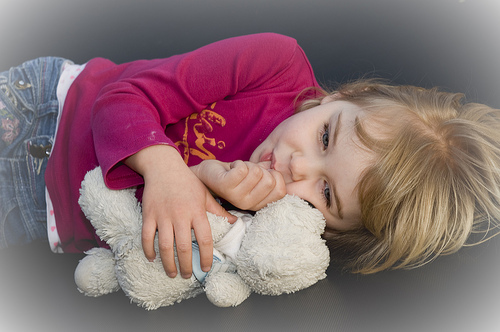<image>
Is there a shirt on the toy? No. The shirt is not positioned on the toy. They may be near each other, but the shirt is not supported by or resting on top of the toy. Where is the teddy bear in relation to the girl? Is it in front of the girl? Yes. The teddy bear is positioned in front of the girl, appearing closer to the camera viewpoint. 